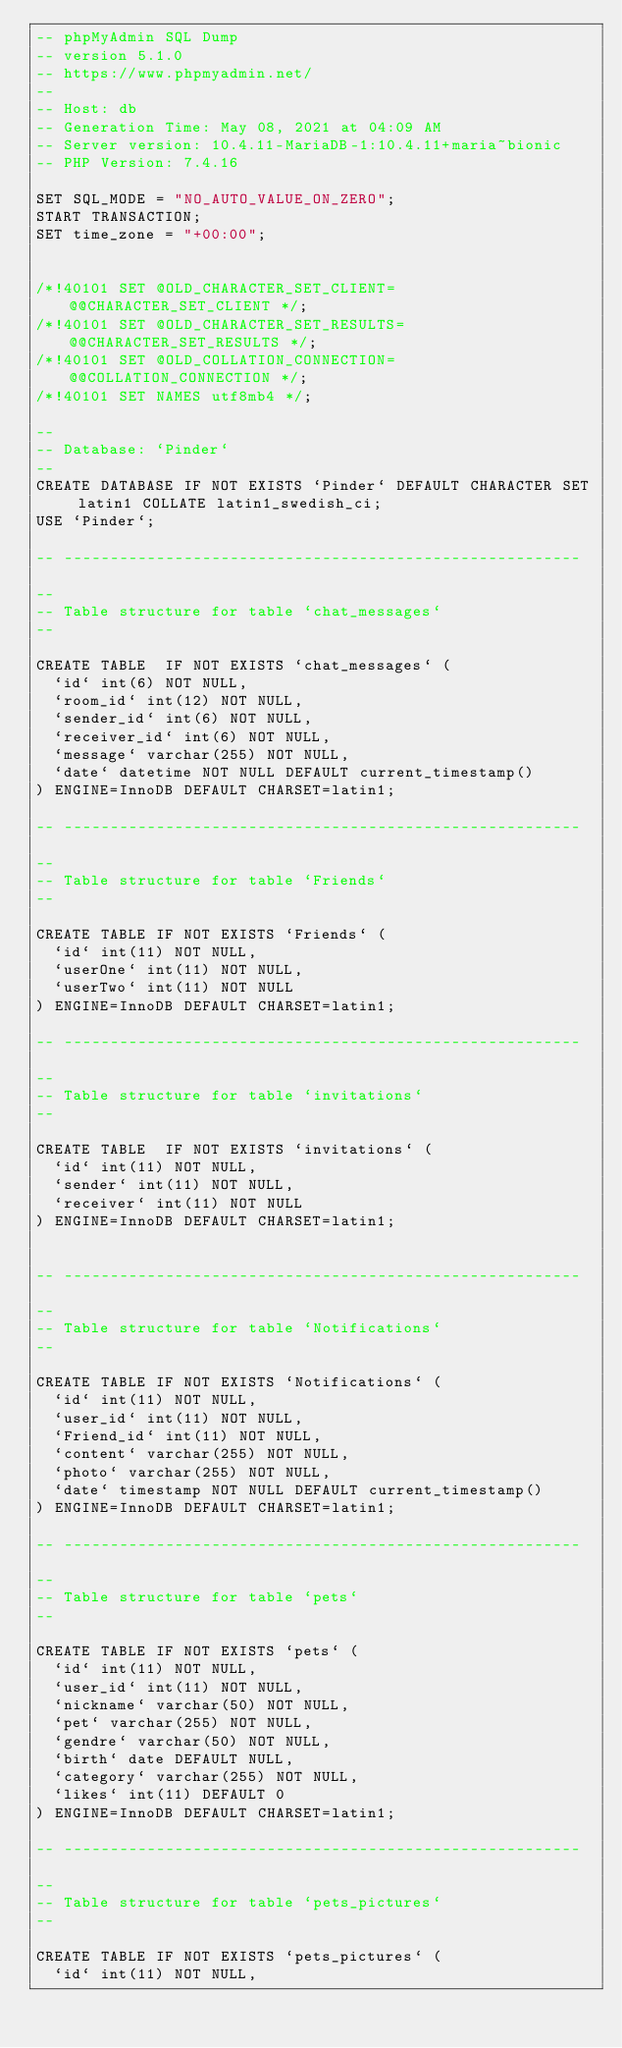Convert code to text. <code><loc_0><loc_0><loc_500><loc_500><_SQL_>-- phpMyAdmin SQL Dump
-- version 5.1.0
-- https://www.phpmyadmin.net/
--
-- Host: db
-- Generation Time: May 08, 2021 at 04:09 AM
-- Server version: 10.4.11-MariaDB-1:10.4.11+maria~bionic
-- PHP Version: 7.4.16

SET SQL_MODE = "NO_AUTO_VALUE_ON_ZERO";
START TRANSACTION;
SET time_zone = "+00:00";


/*!40101 SET @OLD_CHARACTER_SET_CLIENT=@@CHARACTER_SET_CLIENT */;
/*!40101 SET @OLD_CHARACTER_SET_RESULTS=@@CHARACTER_SET_RESULTS */;
/*!40101 SET @OLD_COLLATION_CONNECTION=@@COLLATION_CONNECTION */;
/*!40101 SET NAMES utf8mb4 */;

--
-- Database: `Pinder`
--
CREATE DATABASE IF NOT EXISTS `Pinder` DEFAULT CHARACTER SET latin1 COLLATE latin1_swedish_ci;
USE `Pinder`;

-- --------------------------------------------------------

--
-- Table structure for table `chat_messages`
--

CREATE TABLE  IF NOT EXISTS `chat_messages` (
  `id` int(6) NOT NULL,
  `room_id` int(12) NOT NULL,
  `sender_id` int(6) NOT NULL,
  `receiver_id` int(6) NOT NULL,
  `message` varchar(255) NOT NULL,
  `date` datetime NOT NULL DEFAULT current_timestamp()
) ENGINE=InnoDB DEFAULT CHARSET=latin1;

-- --------------------------------------------------------

--
-- Table structure for table `Friends`
--

CREATE TABLE IF NOT EXISTS `Friends` (
  `id` int(11) NOT NULL,
  `userOne` int(11) NOT NULL,
  `userTwo` int(11) NOT NULL
) ENGINE=InnoDB DEFAULT CHARSET=latin1;

-- --------------------------------------------------------

--
-- Table structure for table `invitations`
--

CREATE TABLE  IF NOT EXISTS `invitations` (
  `id` int(11) NOT NULL,
  `sender` int(11) NOT NULL,
  `receiver` int(11) NOT NULL
) ENGINE=InnoDB DEFAULT CHARSET=latin1;


-- --------------------------------------------------------

--
-- Table structure for table `Notifications`
--

CREATE TABLE IF NOT EXISTS `Notifications` (
  `id` int(11) NOT NULL,
  `user_id` int(11) NOT NULL,
  `Friend_id` int(11) NOT NULL,
  `content` varchar(255) NOT NULL,
  `photo` varchar(255) NOT NULL,
  `date` timestamp NOT NULL DEFAULT current_timestamp()
) ENGINE=InnoDB DEFAULT CHARSET=latin1;

-- --------------------------------------------------------

--
-- Table structure for table `pets`
--

CREATE TABLE IF NOT EXISTS `pets` (
  `id` int(11) NOT NULL,
  `user_id` int(11) NOT NULL,
  `nickname` varchar(50) NOT NULL,
  `pet` varchar(255) NOT NULL,
  `gendre` varchar(50) NOT NULL,
  `birth` date DEFAULT NULL,
  `category` varchar(255) NOT NULL,
  `likes` int(11) DEFAULT 0
) ENGINE=InnoDB DEFAULT CHARSET=latin1;

-- --------------------------------------------------------

--
-- Table structure for table `pets_pictures`
--

CREATE TABLE IF NOT EXISTS `pets_pictures` (
  `id` int(11) NOT NULL,</code> 